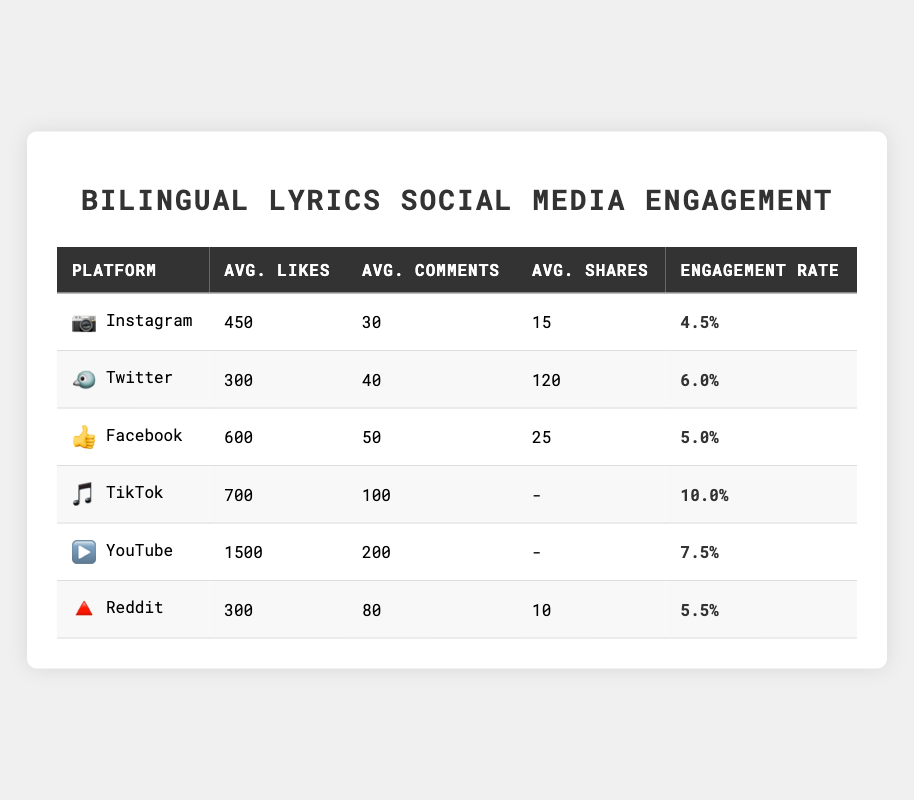What social media platform has the highest average likes for bilingual lyrics posts? Looking at the table, Facebook has the highest average likes with 600.
Answer: Facebook Which platform has the lowest engagement rate for bilingual lyrics posts? The lowest engagement rate listed is 4.5%, which belongs to Instagram.
Answer: Instagram How many total average shares are there across all platforms, excluding TikTok and YouTube? The average shares for the applicable platforms are 15 (Instagram) + 120 (Twitter) + 25 (Facebook) + 10 (Reddit) = 270.
Answer: 270 What is the average engagement rate of Facebook and Reddit combined? The engagement rates for Facebook and Reddit are 5.0% and 5.5%, respectively. Calculating the average gives (5.0 + 5.5) / 2 = 5.25%.
Answer: 5.25% Is the average number of likes on TikTok higher than on Twitter? TikTok has an average of 700 likes, while Twitter has 300 likes, confirming that TikTok is higher.
Answer: Yes What is the total average number of comments for Instagram, Twitter, and Reddit? The average comments are 30 (Instagram) + 40 (Twitter) + 80 (Reddit) = 150.
Answer: 150 Which platform has the highest average comments, and what is that number? The table shows TikTok having the highest average comments at 100.
Answer: 100 If you combine the average likes from YouTube and TikTok, what is the total? YouTube has 1500 likes and TikTok has 700, so the total is 1500 + 700 = 2200.
Answer: 2200 What is the engagement rate difference between YouTube and Instagram? YouTube has an engagement rate of 7.5% and Instagram has 4.5%. The difference is 7.5 - 4.5 = 3.0%.
Answer: 3.0% Are there more average comments on Facebook compared to Instagram? Facebook has 50 comments, while Instagram has 30, indicating that Facebook has more.
Answer: Yes 